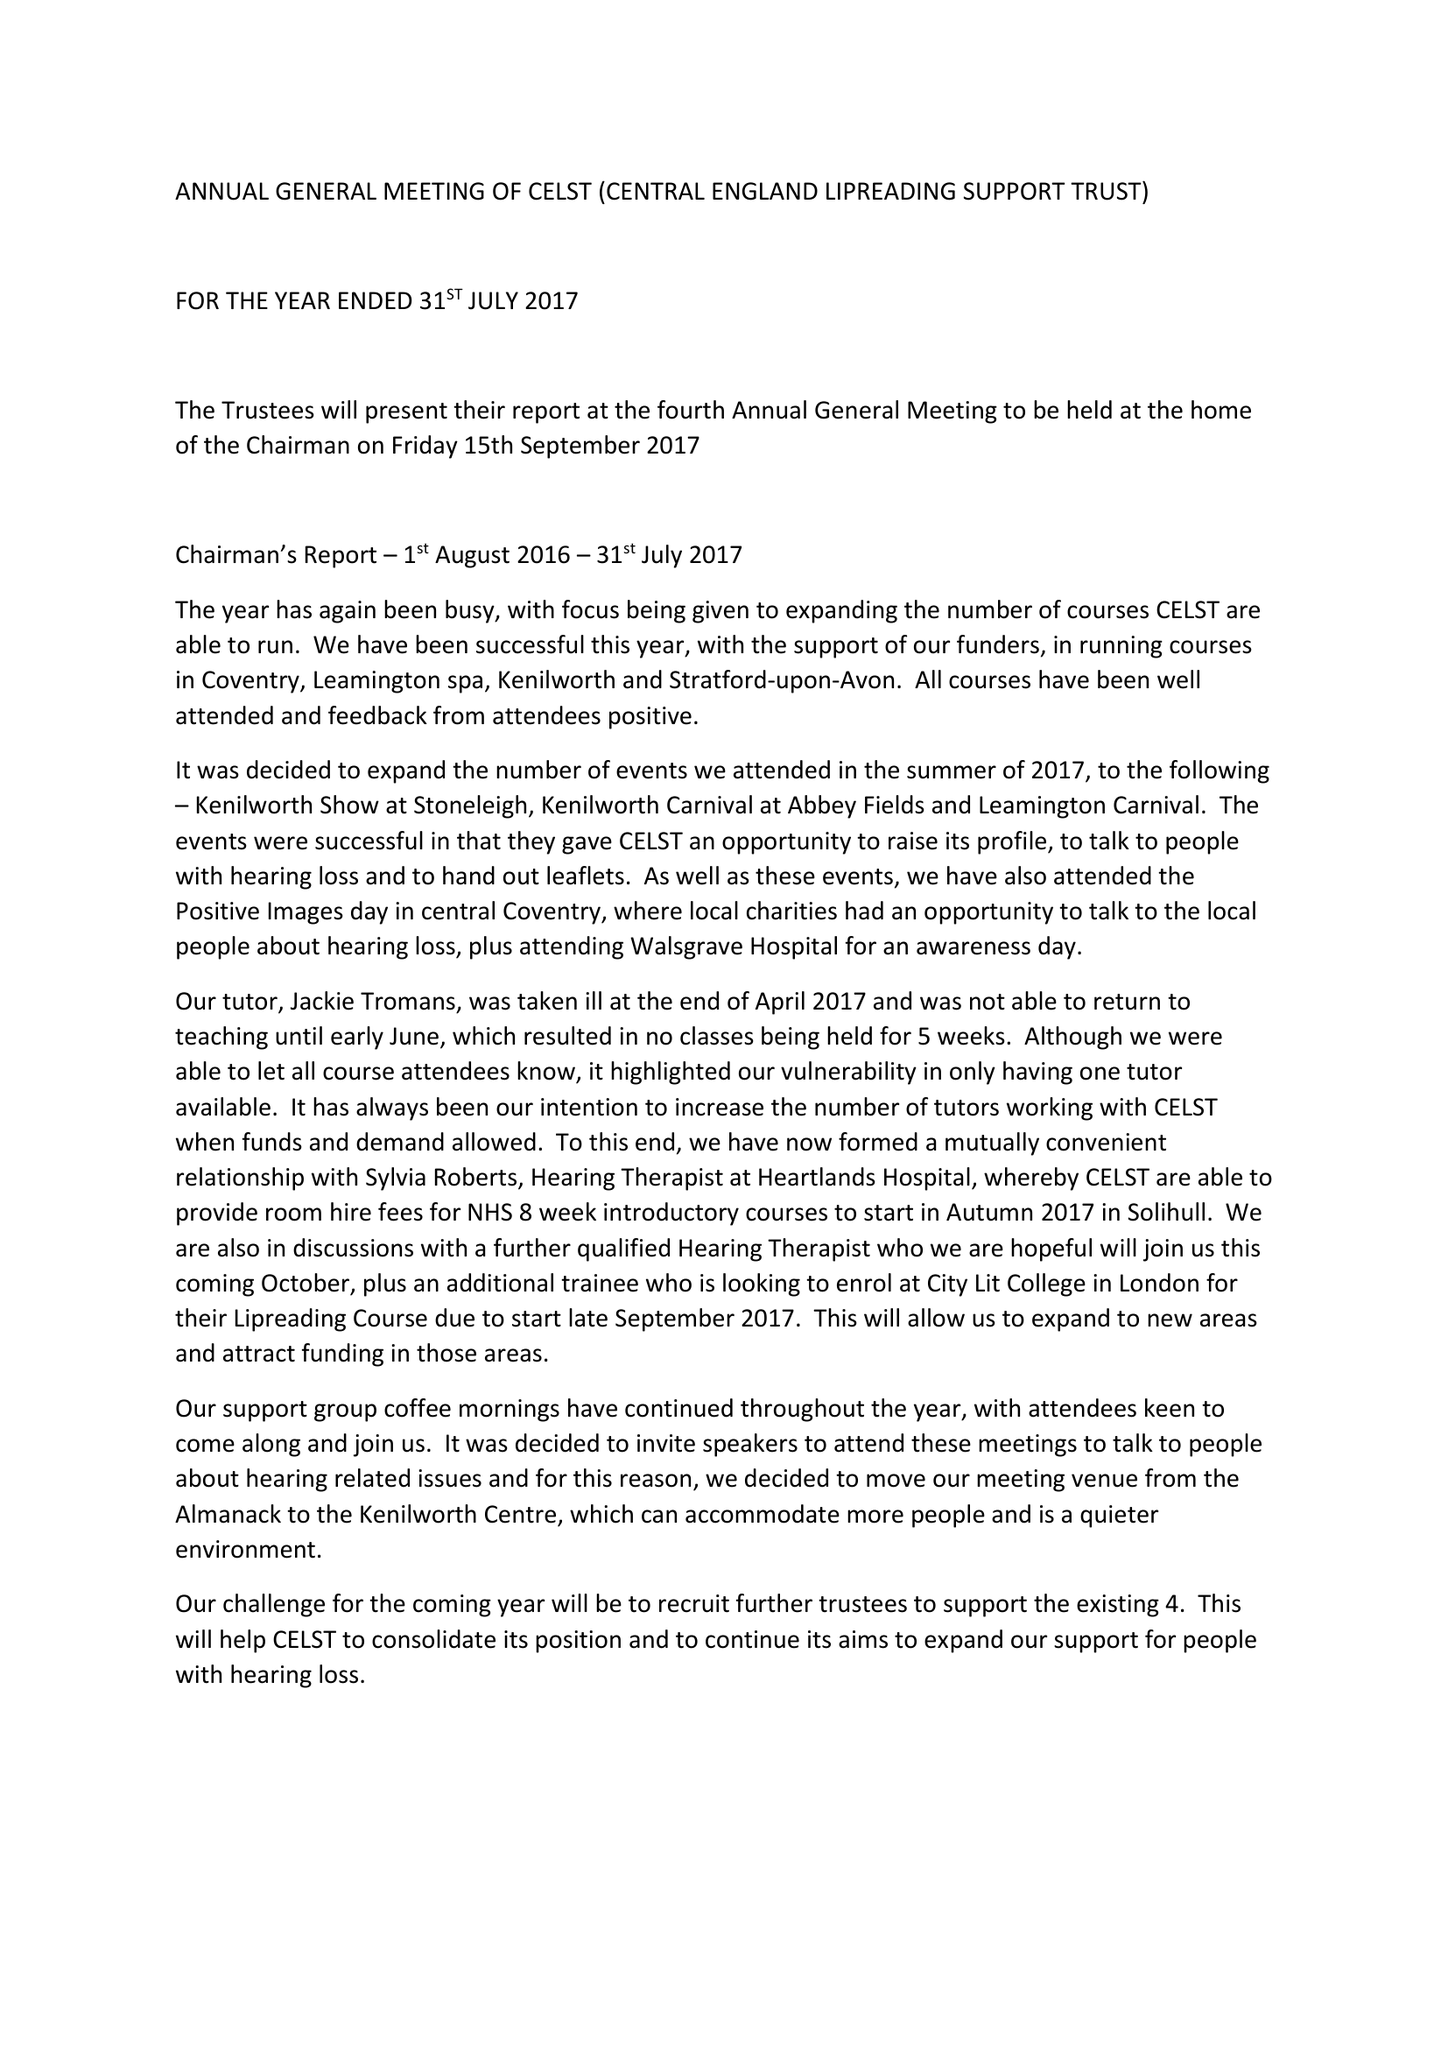What is the value for the report_date?
Answer the question using a single word or phrase. 2017-07-31 